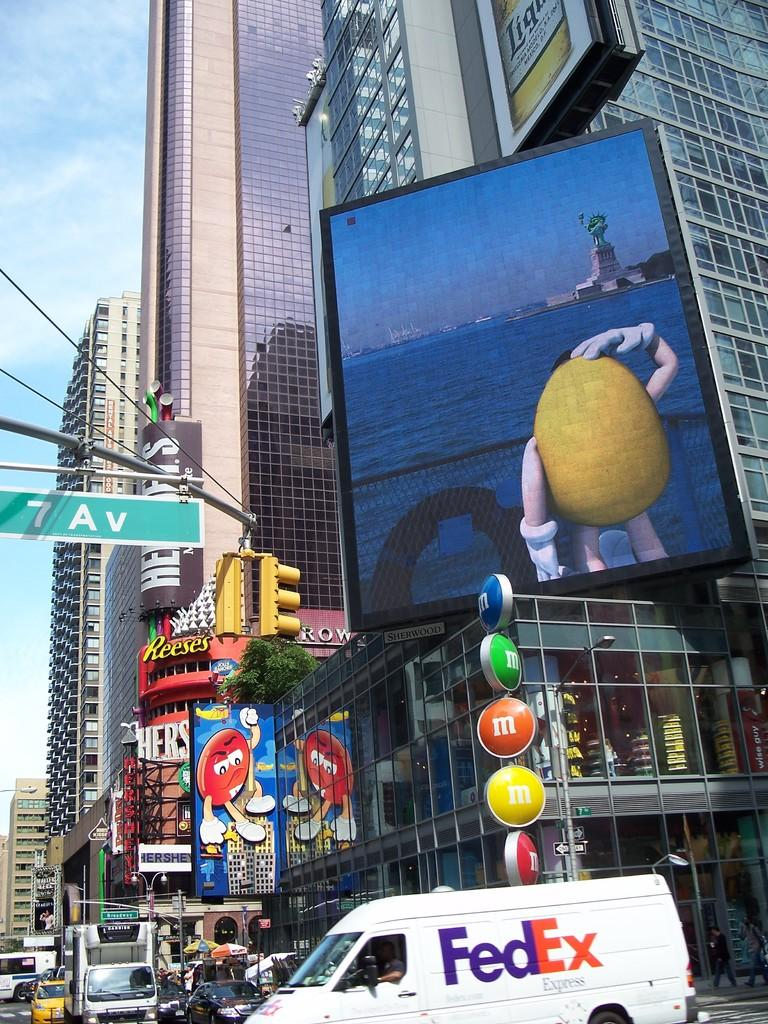<image>
Render a clear and concise summary of the photo. Fedex van is riding in the streets near a m&m sign and street sign 